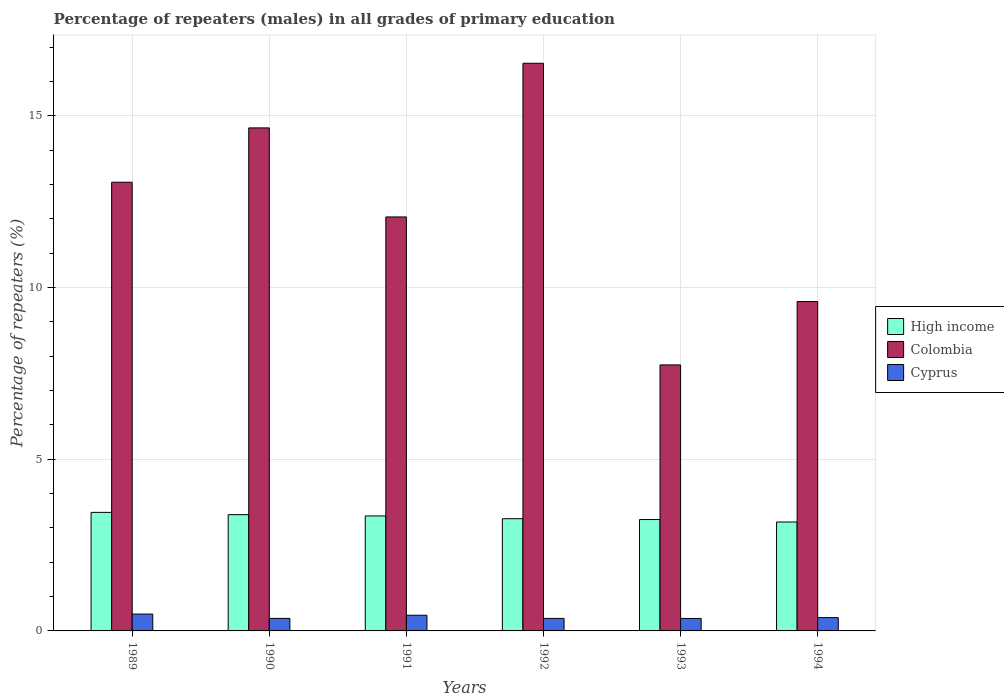How many groups of bars are there?
Offer a terse response. 6. Are the number of bars per tick equal to the number of legend labels?
Ensure brevity in your answer.  Yes. Are the number of bars on each tick of the X-axis equal?
Offer a terse response. Yes. What is the percentage of repeaters (males) in Cyprus in 1992?
Offer a terse response. 0.36. Across all years, what is the maximum percentage of repeaters (males) in Colombia?
Offer a very short reply. 16.53. Across all years, what is the minimum percentage of repeaters (males) in High income?
Offer a terse response. 3.17. In which year was the percentage of repeaters (males) in Colombia maximum?
Provide a short and direct response. 1992. What is the total percentage of repeaters (males) in High income in the graph?
Make the answer very short. 19.87. What is the difference between the percentage of repeaters (males) in Cyprus in 1991 and that in 1992?
Offer a very short reply. 0.09. What is the difference between the percentage of repeaters (males) in Cyprus in 1992 and the percentage of repeaters (males) in High income in 1993?
Keep it short and to the point. -2.88. What is the average percentage of repeaters (males) in Cyprus per year?
Give a very brief answer. 0.4. In the year 1989, what is the difference between the percentage of repeaters (males) in Colombia and percentage of repeaters (males) in Cyprus?
Provide a succinct answer. 12.58. What is the ratio of the percentage of repeaters (males) in Cyprus in 1992 to that in 1994?
Ensure brevity in your answer.  0.94. Is the percentage of repeaters (males) in Colombia in 1989 less than that in 1990?
Provide a short and direct response. Yes. Is the difference between the percentage of repeaters (males) in Colombia in 1992 and 1994 greater than the difference between the percentage of repeaters (males) in Cyprus in 1992 and 1994?
Give a very brief answer. Yes. What is the difference between the highest and the second highest percentage of repeaters (males) in High income?
Offer a terse response. 0.07. What is the difference between the highest and the lowest percentage of repeaters (males) in Cyprus?
Ensure brevity in your answer.  0.13. What does the 1st bar from the left in 1991 represents?
Provide a short and direct response. High income. How many bars are there?
Make the answer very short. 18. Are all the bars in the graph horizontal?
Keep it short and to the point. No. How many years are there in the graph?
Ensure brevity in your answer.  6. What is the difference between two consecutive major ticks on the Y-axis?
Offer a very short reply. 5. Does the graph contain grids?
Provide a succinct answer. Yes. Where does the legend appear in the graph?
Offer a very short reply. Center right. What is the title of the graph?
Your answer should be compact. Percentage of repeaters (males) in all grades of primary education. What is the label or title of the X-axis?
Offer a terse response. Years. What is the label or title of the Y-axis?
Provide a short and direct response. Percentage of repeaters (%). What is the Percentage of repeaters (%) in High income in 1989?
Offer a terse response. 3.45. What is the Percentage of repeaters (%) in Colombia in 1989?
Your response must be concise. 13.07. What is the Percentage of repeaters (%) in Cyprus in 1989?
Ensure brevity in your answer.  0.49. What is the Percentage of repeaters (%) in High income in 1990?
Provide a short and direct response. 3.39. What is the Percentage of repeaters (%) of Colombia in 1990?
Ensure brevity in your answer.  14.65. What is the Percentage of repeaters (%) in Cyprus in 1990?
Your response must be concise. 0.37. What is the Percentage of repeaters (%) in High income in 1991?
Offer a terse response. 3.35. What is the Percentage of repeaters (%) in Colombia in 1991?
Ensure brevity in your answer.  12.06. What is the Percentage of repeaters (%) in Cyprus in 1991?
Ensure brevity in your answer.  0.46. What is the Percentage of repeaters (%) of High income in 1992?
Your answer should be very brief. 3.27. What is the Percentage of repeaters (%) in Colombia in 1992?
Provide a short and direct response. 16.53. What is the Percentage of repeaters (%) of Cyprus in 1992?
Your answer should be very brief. 0.36. What is the Percentage of repeaters (%) of High income in 1993?
Give a very brief answer. 3.24. What is the Percentage of repeaters (%) of Colombia in 1993?
Provide a short and direct response. 7.75. What is the Percentage of repeaters (%) of Cyprus in 1993?
Your answer should be compact. 0.36. What is the Percentage of repeaters (%) in High income in 1994?
Offer a terse response. 3.17. What is the Percentage of repeaters (%) of Colombia in 1994?
Give a very brief answer. 9.59. What is the Percentage of repeaters (%) of Cyprus in 1994?
Your answer should be compact. 0.39. Across all years, what is the maximum Percentage of repeaters (%) in High income?
Make the answer very short. 3.45. Across all years, what is the maximum Percentage of repeaters (%) of Colombia?
Your answer should be very brief. 16.53. Across all years, what is the maximum Percentage of repeaters (%) of Cyprus?
Provide a short and direct response. 0.49. Across all years, what is the minimum Percentage of repeaters (%) in High income?
Keep it short and to the point. 3.17. Across all years, what is the minimum Percentage of repeaters (%) in Colombia?
Provide a short and direct response. 7.75. Across all years, what is the minimum Percentage of repeaters (%) of Cyprus?
Make the answer very short. 0.36. What is the total Percentage of repeaters (%) of High income in the graph?
Your response must be concise. 19.87. What is the total Percentage of repeaters (%) of Colombia in the graph?
Keep it short and to the point. 73.65. What is the total Percentage of repeaters (%) of Cyprus in the graph?
Offer a very short reply. 2.43. What is the difference between the Percentage of repeaters (%) of High income in 1989 and that in 1990?
Your response must be concise. 0.07. What is the difference between the Percentage of repeaters (%) of Colombia in 1989 and that in 1990?
Provide a succinct answer. -1.58. What is the difference between the Percentage of repeaters (%) of Cyprus in 1989 and that in 1990?
Your response must be concise. 0.13. What is the difference between the Percentage of repeaters (%) in High income in 1989 and that in 1991?
Ensure brevity in your answer.  0.1. What is the difference between the Percentage of repeaters (%) of Colombia in 1989 and that in 1991?
Your answer should be compact. 1.01. What is the difference between the Percentage of repeaters (%) in Cyprus in 1989 and that in 1991?
Offer a very short reply. 0.03. What is the difference between the Percentage of repeaters (%) in High income in 1989 and that in 1992?
Provide a succinct answer. 0.18. What is the difference between the Percentage of repeaters (%) in Colombia in 1989 and that in 1992?
Keep it short and to the point. -3.46. What is the difference between the Percentage of repeaters (%) in Cyprus in 1989 and that in 1992?
Provide a short and direct response. 0.13. What is the difference between the Percentage of repeaters (%) in High income in 1989 and that in 1993?
Your answer should be very brief. 0.21. What is the difference between the Percentage of repeaters (%) in Colombia in 1989 and that in 1993?
Offer a terse response. 5.32. What is the difference between the Percentage of repeaters (%) in Cyprus in 1989 and that in 1993?
Ensure brevity in your answer.  0.13. What is the difference between the Percentage of repeaters (%) of High income in 1989 and that in 1994?
Your response must be concise. 0.28. What is the difference between the Percentage of repeaters (%) in Colombia in 1989 and that in 1994?
Keep it short and to the point. 3.47. What is the difference between the Percentage of repeaters (%) in Cyprus in 1989 and that in 1994?
Offer a terse response. 0.1. What is the difference between the Percentage of repeaters (%) of High income in 1990 and that in 1991?
Give a very brief answer. 0.04. What is the difference between the Percentage of repeaters (%) of Colombia in 1990 and that in 1991?
Make the answer very short. 2.59. What is the difference between the Percentage of repeaters (%) of Cyprus in 1990 and that in 1991?
Make the answer very short. -0.09. What is the difference between the Percentage of repeaters (%) in High income in 1990 and that in 1992?
Provide a short and direct response. 0.12. What is the difference between the Percentage of repeaters (%) of Colombia in 1990 and that in 1992?
Make the answer very short. -1.88. What is the difference between the Percentage of repeaters (%) in Cyprus in 1990 and that in 1992?
Offer a terse response. 0. What is the difference between the Percentage of repeaters (%) in High income in 1990 and that in 1993?
Keep it short and to the point. 0.14. What is the difference between the Percentage of repeaters (%) of Colombia in 1990 and that in 1993?
Your answer should be compact. 6.9. What is the difference between the Percentage of repeaters (%) of Cyprus in 1990 and that in 1993?
Provide a succinct answer. 0. What is the difference between the Percentage of repeaters (%) in High income in 1990 and that in 1994?
Your response must be concise. 0.21. What is the difference between the Percentage of repeaters (%) of Colombia in 1990 and that in 1994?
Your answer should be compact. 5.06. What is the difference between the Percentage of repeaters (%) in Cyprus in 1990 and that in 1994?
Your answer should be compact. -0.02. What is the difference between the Percentage of repeaters (%) in High income in 1991 and that in 1992?
Make the answer very short. 0.08. What is the difference between the Percentage of repeaters (%) of Colombia in 1991 and that in 1992?
Offer a terse response. -4.48. What is the difference between the Percentage of repeaters (%) in Cyprus in 1991 and that in 1992?
Your answer should be very brief. 0.09. What is the difference between the Percentage of repeaters (%) of High income in 1991 and that in 1993?
Offer a very short reply. 0.1. What is the difference between the Percentage of repeaters (%) in Colombia in 1991 and that in 1993?
Your response must be concise. 4.31. What is the difference between the Percentage of repeaters (%) in Cyprus in 1991 and that in 1993?
Offer a terse response. 0.09. What is the difference between the Percentage of repeaters (%) of High income in 1991 and that in 1994?
Provide a succinct answer. 0.18. What is the difference between the Percentage of repeaters (%) of Colombia in 1991 and that in 1994?
Your answer should be compact. 2.46. What is the difference between the Percentage of repeaters (%) of Cyprus in 1991 and that in 1994?
Keep it short and to the point. 0.07. What is the difference between the Percentage of repeaters (%) in High income in 1992 and that in 1993?
Ensure brevity in your answer.  0.02. What is the difference between the Percentage of repeaters (%) of Colombia in 1992 and that in 1993?
Your answer should be very brief. 8.79. What is the difference between the Percentage of repeaters (%) in High income in 1992 and that in 1994?
Your answer should be very brief. 0.1. What is the difference between the Percentage of repeaters (%) in Colombia in 1992 and that in 1994?
Your answer should be compact. 6.94. What is the difference between the Percentage of repeaters (%) in Cyprus in 1992 and that in 1994?
Give a very brief answer. -0.02. What is the difference between the Percentage of repeaters (%) of High income in 1993 and that in 1994?
Your response must be concise. 0.07. What is the difference between the Percentage of repeaters (%) of Colombia in 1993 and that in 1994?
Give a very brief answer. -1.85. What is the difference between the Percentage of repeaters (%) in Cyprus in 1993 and that in 1994?
Provide a short and direct response. -0.02. What is the difference between the Percentage of repeaters (%) of High income in 1989 and the Percentage of repeaters (%) of Colombia in 1990?
Make the answer very short. -11.2. What is the difference between the Percentage of repeaters (%) in High income in 1989 and the Percentage of repeaters (%) in Cyprus in 1990?
Provide a short and direct response. 3.09. What is the difference between the Percentage of repeaters (%) of Colombia in 1989 and the Percentage of repeaters (%) of Cyprus in 1990?
Your response must be concise. 12.7. What is the difference between the Percentage of repeaters (%) of High income in 1989 and the Percentage of repeaters (%) of Colombia in 1991?
Make the answer very short. -8.6. What is the difference between the Percentage of repeaters (%) in High income in 1989 and the Percentage of repeaters (%) in Cyprus in 1991?
Offer a terse response. 3. What is the difference between the Percentage of repeaters (%) in Colombia in 1989 and the Percentage of repeaters (%) in Cyprus in 1991?
Offer a very short reply. 12.61. What is the difference between the Percentage of repeaters (%) of High income in 1989 and the Percentage of repeaters (%) of Colombia in 1992?
Your response must be concise. -13.08. What is the difference between the Percentage of repeaters (%) in High income in 1989 and the Percentage of repeaters (%) in Cyprus in 1992?
Your answer should be very brief. 3.09. What is the difference between the Percentage of repeaters (%) in Colombia in 1989 and the Percentage of repeaters (%) in Cyprus in 1992?
Provide a succinct answer. 12.7. What is the difference between the Percentage of repeaters (%) in High income in 1989 and the Percentage of repeaters (%) in Colombia in 1993?
Ensure brevity in your answer.  -4.3. What is the difference between the Percentage of repeaters (%) in High income in 1989 and the Percentage of repeaters (%) in Cyprus in 1993?
Provide a short and direct response. 3.09. What is the difference between the Percentage of repeaters (%) of Colombia in 1989 and the Percentage of repeaters (%) of Cyprus in 1993?
Your answer should be very brief. 12.7. What is the difference between the Percentage of repeaters (%) of High income in 1989 and the Percentage of repeaters (%) of Colombia in 1994?
Offer a terse response. -6.14. What is the difference between the Percentage of repeaters (%) of High income in 1989 and the Percentage of repeaters (%) of Cyprus in 1994?
Give a very brief answer. 3.06. What is the difference between the Percentage of repeaters (%) of Colombia in 1989 and the Percentage of repeaters (%) of Cyprus in 1994?
Your response must be concise. 12.68. What is the difference between the Percentage of repeaters (%) in High income in 1990 and the Percentage of repeaters (%) in Colombia in 1991?
Offer a very short reply. -8.67. What is the difference between the Percentage of repeaters (%) in High income in 1990 and the Percentage of repeaters (%) in Cyprus in 1991?
Your answer should be compact. 2.93. What is the difference between the Percentage of repeaters (%) of Colombia in 1990 and the Percentage of repeaters (%) of Cyprus in 1991?
Offer a terse response. 14.19. What is the difference between the Percentage of repeaters (%) in High income in 1990 and the Percentage of repeaters (%) in Colombia in 1992?
Make the answer very short. -13.15. What is the difference between the Percentage of repeaters (%) of High income in 1990 and the Percentage of repeaters (%) of Cyprus in 1992?
Ensure brevity in your answer.  3.02. What is the difference between the Percentage of repeaters (%) in Colombia in 1990 and the Percentage of repeaters (%) in Cyprus in 1992?
Make the answer very short. 14.29. What is the difference between the Percentage of repeaters (%) in High income in 1990 and the Percentage of repeaters (%) in Colombia in 1993?
Provide a succinct answer. -4.36. What is the difference between the Percentage of repeaters (%) of High income in 1990 and the Percentage of repeaters (%) of Cyprus in 1993?
Keep it short and to the point. 3.02. What is the difference between the Percentage of repeaters (%) in Colombia in 1990 and the Percentage of repeaters (%) in Cyprus in 1993?
Give a very brief answer. 14.29. What is the difference between the Percentage of repeaters (%) of High income in 1990 and the Percentage of repeaters (%) of Colombia in 1994?
Your answer should be compact. -6.21. What is the difference between the Percentage of repeaters (%) in High income in 1990 and the Percentage of repeaters (%) in Cyprus in 1994?
Provide a short and direct response. 3. What is the difference between the Percentage of repeaters (%) in Colombia in 1990 and the Percentage of repeaters (%) in Cyprus in 1994?
Make the answer very short. 14.26. What is the difference between the Percentage of repeaters (%) in High income in 1991 and the Percentage of repeaters (%) in Colombia in 1992?
Provide a short and direct response. -13.18. What is the difference between the Percentage of repeaters (%) of High income in 1991 and the Percentage of repeaters (%) of Cyprus in 1992?
Provide a succinct answer. 2.98. What is the difference between the Percentage of repeaters (%) of Colombia in 1991 and the Percentage of repeaters (%) of Cyprus in 1992?
Ensure brevity in your answer.  11.69. What is the difference between the Percentage of repeaters (%) in High income in 1991 and the Percentage of repeaters (%) in Colombia in 1993?
Your answer should be very brief. -4.4. What is the difference between the Percentage of repeaters (%) in High income in 1991 and the Percentage of repeaters (%) in Cyprus in 1993?
Provide a succinct answer. 2.99. What is the difference between the Percentage of repeaters (%) of Colombia in 1991 and the Percentage of repeaters (%) of Cyprus in 1993?
Your answer should be very brief. 11.69. What is the difference between the Percentage of repeaters (%) of High income in 1991 and the Percentage of repeaters (%) of Colombia in 1994?
Your response must be concise. -6.25. What is the difference between the Percentage of repeaters (%) in High income in 1991 and the Percentage of repeaters (%) in Cyprus in 1994?
Provide a short and direct response. 2.96. What is the difference between the Percentage of repeaters (%) of Colombia in 1991 and the Percentage of repeaters (%) of Cyprus in 1994?
Ensure brevity in your answer.  11.67. What is the difference between the Percentage of repeaters (%) of High income in 1992 and the Percentage of repeaters (%) of Colombia in 1993?
Your response must be concise. -4.48. What is the difference between the Percentage of repeaters (%) of High income in 1992 and the Percentage of repeaters (%) of Cyprus in 1993?
Keep it short and to the point. 2.9. What is the difference between the Percentage of repeaters (%) of Colombia in 1992 and the Percentage of repeaters (%) of Cyprus in 1993?
Your answer should be very brief. 16.17. What is the difference between the Percentage of repeaters (%) in High income in 1992 and the Percentage of repeaters (%) in Colombia in 1994?
Make the answer very short. -6.33. What is the difference between the Percentage of repeaters (%) in High income in 1992 and the Percentage of repeaters (%) in Cyprus in 1994?
Keep it short and to the point. 2.88. What is the difference between the Percentage of repeaters (%) in Colombia in 1992 and the Percentage of repeaters (%) in Cyprus in 1994?
Your answer should be compact. 16.14. What is the difference between the Percentage of repeaters (%) in High income in 1993 and the Percentage of repeaters (%) in Colombia in 1994?
Make the answer very short. -6.35. What is the difference between the Percentage of repeaters (%) in High income in 1993 and the Percentage of repeaters (%) in Cyprus in 1994?
Your answer should be compact. 2.86. What is the difference between the Percentage of repeaters (%) in Colombia in 1993 and the Percentage of repeaters (%) in Cyprus in 1994?
Offer a terse response. 7.36. What is the average Percentage of repeaters (%) of High income per year?
Offer a very short reply. 3.31. What is the average Percentage of repeaters (%) of Colombia per year?
Your response must be concise. 12.27. What is the average Percentage of repeaters (%) in Cyprus per year?
Give a very brief answer. 0.4. In the year 1989, what is the difference between the Percentage of repeaters (%) of High income and Percentage of repeaters (%) of Colombia?
Provide a succinct answer. -9.62. In the year 1989, what is the difference between the Percentage of repeaters (%) of High income and Percentage of repeaters (%) of Cyprus?
Make the answer very short. 2.96. In the year 1989, what is the difference between the Percentage of repeaters (%) in Colombia and Percentage of repeaters (%) in Cyprus?
Make the answer very short. 12.58. In the year 1990, what is the difference between the Percentage of repeaters (%) in High income and Percentage of repeaters (%) in Colombia?
Your answer should be very brief. -11.26. In the year 1990, what is the difference between the Percentage of repeaters (%) of High income and Percentage of repeaters (%) of Cyprus?
Keep it short and to the point. 3.02. In the year 1990, what is the difference between the Percentage of repeaters (%) of Colombia and Percentage of repeaters (%) of Cyprus?
Provide a succinct answer. 14.28. In the year 1991, what is the difference between the Percentage of repeaters (%) of High income and Percentage of repeaters (%) of Colombia?
Ensure brevity in your answer.  -8.71. In the year 1991, what is the difference between the Percentage of repeaters (%) of High income and Percentage of repeaters (%) of Cyprus?
Your response must be concise. 2.89. In the year 1991, what is the difference between the Percentage of repeaters (%) in Colombia and Percentage of repeaters (%) in Cyprus?
Your answer should be compact. 11.6. In the year 1992, what is the difference between the Percentage of repeaters (%) in High income and Percentage of repeaters (%) in Colombia?
Ensure brevity in your answer.  -13.26. In the year 1992, what is the difference between the Percentage of repeaters (%) in High income and Percentage of repeaters (%) in Cyprus?
Give a very brief answer. 2.9. In the year 1992, what is the difference between the Percentage of repeaters (%) of Colombia and Percentage of repeaters (%) of Cyprus?
Keep it short and to the point. 16.17. In the year 1993, what is the difference between the Percentage of repeaters (%) in High income and Percentage of repeaters (%) in Colombia?
Provide a succinct answer. -4.5. In the year 1993, what is the difference between the Percentage of repeaters (%) of High income and Percentage of repeaters (%) of Cyprus?
Make the answer very short. 2.88. In the year 1993, what is the difference between the Percentage of repeaters (%) in Colombia and Percentage of repeaters (%) in Cyprus?
Your answer should be very brief. 7.38. In the year 1994, what is the difference between the Percentage of repeaters (%) of High income and Percentage of repeaters (%) of Colombia?
Make the answer very short. -6.42. In the year 1994, what is the difference between the Percentage of repeaters (%) of High income and Percentage of repeaters (%) of Cyprus?
Give a very brief answer. 2.78. In the year 1994, what is the difference between the Percentage of repeaters (%) of Colombia and Percentage of repeaters (%) of Cyprus?
Your answer should be very brief. 9.21. What is the ratio of the Percentage of repeaters (%) of High income in 1989 to that in 1990?
Provide a short and direct response. 1.02. What is the ratio of the Percentage of repeaters (%) of Colombia in 1989 to that in 1990?
Your response must be concise. 0.89. What is the ratio of the Percentage of repeaters (%) in Cyprus in 1989 to that in 1990?
Give a very brief answer. 1.34. What is the ratio of the Percentage of repeaters (%) of High income in 1989 to that in 1991?
Your answer should be compact. 1.03. What is the ratio of the Percentage of repeaters (%) of Colombia in 1989 to that in 1991?
Ensure brevity in your answer.  1.08. What is the ratio of the Percentage of repeaters (%) of Cyprus in 1989 to that in 1991?
Your answer should be very brief. 1.07. What is the ratio of the Percentage of repeaters (%) of High income in 1989 to that in 1992?
Make the answer very short. 1.06. What is the ratio of the Percentage of repeaters (%) in Colombia in 1989 to that in 1992?
Your answer should be very brief. 0.79. What is the ratio of the Percentage of repeaters (%) in Cyprus in 1989 to that in 1992?
Your response must be concise. 1.35. What is the ratio of the Percentage of repeaters (%) of High income in 1989 to that in 1993?
Your answer should be very brief. 1.06. What is the ratio of the Percentage of repeaters (%) of Colombia in 1989 to that in 1993?
Keep it short and to the point. 1.69. What is the ratio of the Percentage of repeaters (%) in Cyprus in 1989 to that in 1993?
Make the answer very short. 1.35. What is the ratio of the Percentage of repeaters (%) in High income in 1989 to that in 1994?
Your answer should be compact. 1.09. What is the ratio of the Percentage of repeaters (%) in Colombia in 1989 to that in 1994?
Ensure brevity in your answer.  1.36. What is the ratio of the Percentage of repeaters (%) of Cyprus in 1989 to that in 1994?
Your answer should be compact. 1.27. What is the ratio of the Percentage of repeaters (%) in High income in 1990 to that in 1991?
Offer a very short reply. 1.01. What is the ratio of the Percentage of repeaters (%) in Colombia in 1990 to that in 1991?
Provide a succinct answer. 1.22. What is the ratio of the Percentage of repeaters (%) of Cyprus in 1990 to that in 1991?
Keep it short and to the point. 0.8. What is the ratio of the Percentage of repeaters (%) of High income in 1990 to that in 1992?
Ensure brevity in your answer.  1.04. What is the ratio of the Percentage of repeaters (%) in Colombia in 1990 to that in 1992?
Offer a very short reply. 0.89. What is the ratio of the Percentage of repeaters (%) in Cyprus in 1990 to that in 1992?
Your answer should be very brief. 1. What is the ratio of the Percentage of repeaters (%) of High income in 1990 to that in 1993?
Make the answer very short. 1.04. What is the ratio of the Percentage of repeaters (%) in Colombia in 1990 to that in 1993?
Provide a succinct answer. 1.89. What is the ratio of the Percentage of repeaters (%) in Cyprus in 1990 to that in 1993?
Keep it short and to the point. 1.01. What is the ratio of the Percentage of repeaters (%) in High income in 1990 to that in 1994?
Keep it short and to the point. 1.07. What is the ratio of the Percentage of repeaters (%) in Colombia in 1990 to that in 1994?
Give a very brief answer. 1.53. What is the ratio of the Percentage of repeaters (%) of Cyprus in 1990 to that in 1994?
Give a very brief answer. 0.94. What is the ratio of the Percentage of repeaters (%) in High income in 1991 to that in 1992?
Keep it short and to the point. 1.02. What is the ratio of the Percentage of repeaters (%) of Colombia in 1991 to that in 1992?
Offer a very short reply. 0.73. What is the ratio of the Percentage of repeaters (%) of Cyprus in 1991 to that in 1992?
Provide a short and direct response. 1.26. What is the ratio of the Percentage of repeaters (%) of High income in 1991 to that in 1993?
Your answer should be compact. 1.03. What is the ratio of the Percentage of repeaters (%) of Colombia in 1991 to that in 1993?
Provide a succinct answer. 1.56. What is the ratio of the Percentage of repeaters (%) in Cyprus in 1991 to that in 1993?
Make the answer very short. 1.26. What is the ratio of the Percentage of repeaters (%) in High income in 1991 to that in 1994?
Provide a succinct answer. 1.06. What is the ratio of the Percentage of repeaters (%) in Colombia in 1991 to that in 1994?
Provide a short and direct response. 1.26. What is the ratio of the Percentage of repeaters (%) in Cyprus in 1991 to that in 1994?
Your response must be concise. 1.18. What is the ratio of the Percentage of repeaters (%) in High income in 1992 to that in 1993?
Provide a succinct answer. 1.01. What is the ratio of the Percentage of repeaters (%) of Colombia in 1992 to that in 1993?
Offer a terse response. 2.13. What is the ratio of the Percentage of repeaters (%) in High income in 1992 to that in 1994?
Provide a short and direct response. 1.03. What is the ratio of the Percentage of repeaters (%) of Colombia in 1992 to that in 1994?
Your answer should be compact. 1.72. What is the ratio of the Percentage of repeaters (%) in Cyprus in 1992 to that in 1994?
Offer a very short reply. 0.94. What is the ratio of the Percentage of repeaters (%) in High income in 1993 to that in 1994?
Provide a succinct answer. 1.02. What is the ratio of the Percentage of repeaters (%) of Colombia in 1993 to that in 1994?
Your response must be concise. 0.81. What is the ratio of the Percentage of repeaters (%) of Cyprus in 1993 to that in 1994?
Give a very brief answer. 0.94. What is the difference between the highest and the second highest Percentage of repeaters (%) in High income?
Your response must be concise. 0.07. What is the difference between the highest and the second highest Percentage of repeaters (%) of Colombia?
Offer a terse response. 1.88. What is the difference between the highest and the second highest Percentage of repeaters (%) in Cyprus?
Offer a very short reply. 0.03. What is the difference between the highest and the lowest Percentage of repeaters (%) in High income?
Ensure brevity in your answer.  0.28. What is the difference between the highest and the lowest Percentage of repeaters (%) in Colombia?
Provide a short and direct response. 8.79. What is the difference between the highest and the lowest Percentage of repeaters (%) in Cyprus?
Your response must be concise. 0.13. 